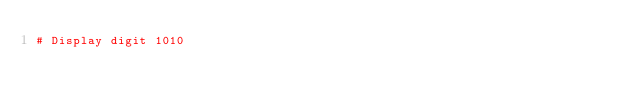<code> <loc_0><loc_0><loc_500><loc_500><_Python_># Display digit 1010</code> 